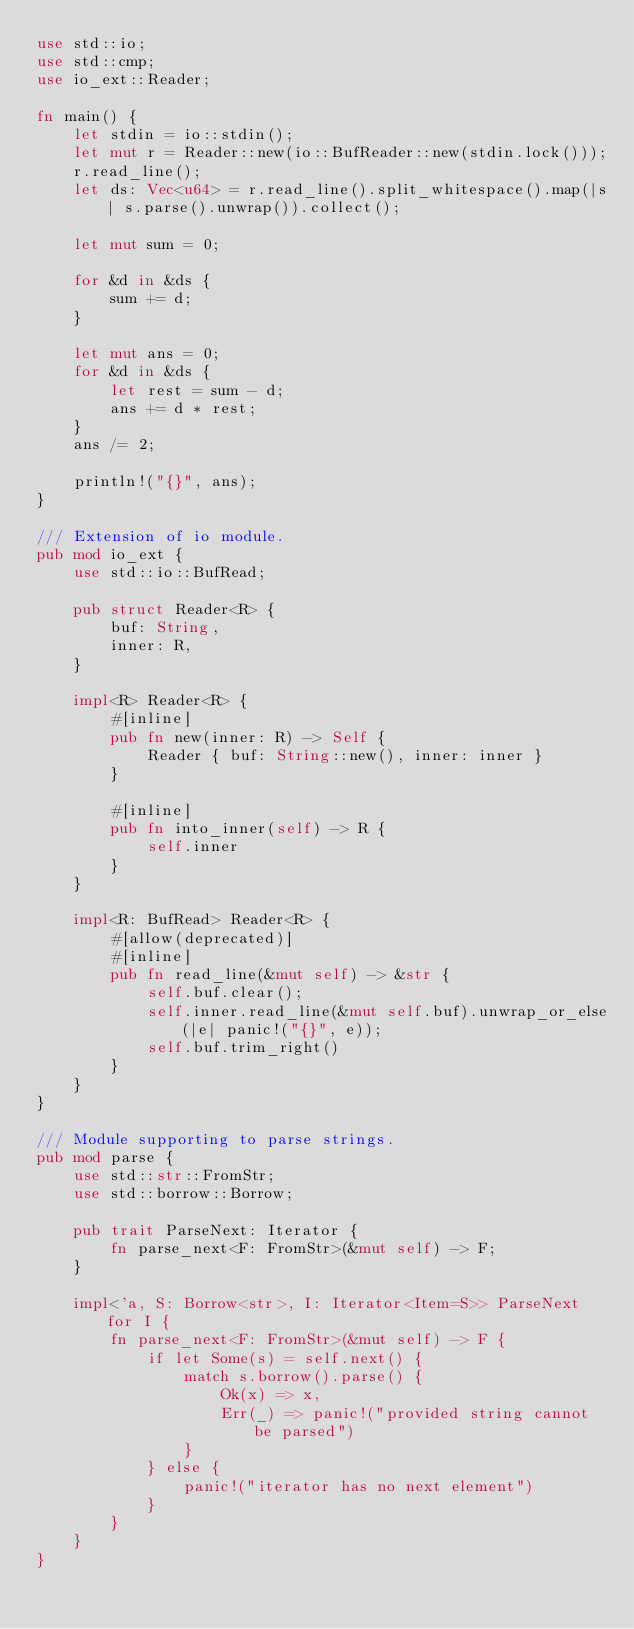Convert code to text. <code><loc_0><loc_0><loc_500><loc_500><_Rust_>use std::io;
use std::cmp;
use io_ext::Reader;

fn main() {
    let stdin = io::stdin();
    let mut r = Reader::new(io::BufReader::new(stdin.lock()));
    r.read_line();
    let ds: Vec<u64> = r.read_line().split_whitespace().map(|s| s.parse().unwrap()).collect();

    let mut sum = 0;
    
    for &d in &ds {
        sum += d;
    }

    let mut ans = 0;
    for &d in &ds {
        let rest = sum - d;
        ans += d * rest;
    }
    ans /= 2;

    println!("{}", ans);
}

/// Extension of io module.
pub mod io_ext {
    use std::io::BufRead;

    pub struct Reader<R> {
        buf: String,
        inner: R,
    }

    impl<R> Reader<R> {
        #[inline]
        pub fn new(inner: R) -> Self {
            Reader { buf: String::new(), inner: inner }
        }

        #[inline]
        pub fn into_inner(self) -> R {
            self.inner
        }
    }

    impl<R: BufRead> Reader<R> {
        #[allow(deprecated)]
        #[inline]
        pub fn read_line(&mut self) -> &str {
            self.buf.clear();
            self.inner.read_line(&mut self.buf).unwrap_or_else(|e| panic!("{}", e));
            self.buf.trim_right()
        }
    }
}

/// Module supporting to parse strings.
pub mod parse {
    use std::str::FromStr;
    use std::borrow::Borrow;

    pub trait ParseNext: Iterator {
        fn parse_next<F: FromStr>(&mut self) -> F;
    }

    impl<'a, S: Borrow<str>, I: Iterator<Item=S>> ParseNext for I {
        fn parse_next<F: FromStr>(&mut self) -> F {
            if let Some(s) = self.next() {
                match s.borrow().parse() {
                    Ok(x) => x,
                    Err(_) => panic!("provided string cannot be parsed")
                }
            } else {
                panic!("iterator has no next element")
            }
        }
    }
}
</code> 